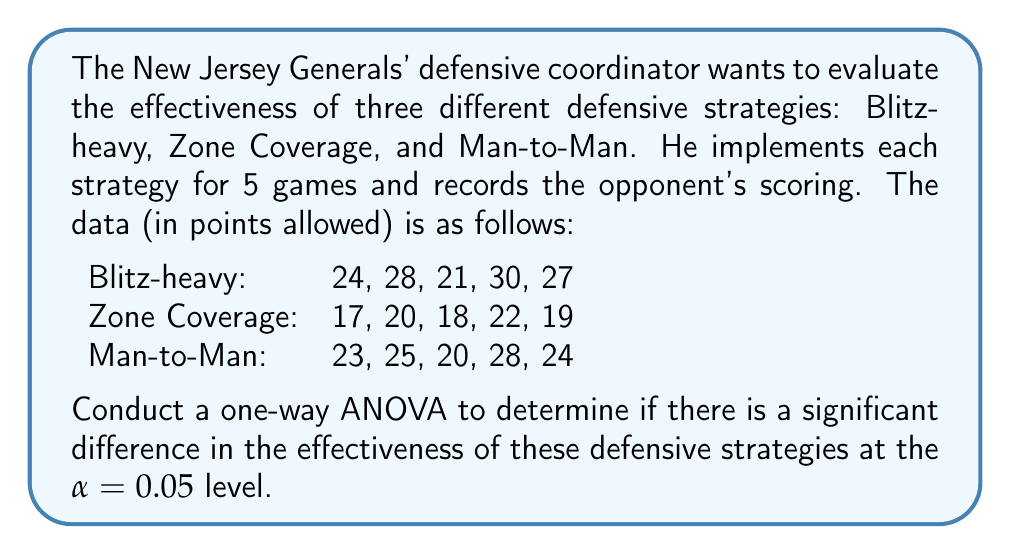Can you answer this question? To conduct a one-way ANOVA, we'll follow these steps:

1. Calculate the sum of squares between groups (SSB), within groups (SSW), and total (SST).
2. Calculate the degrees of freedom for between groups (dfB), within groups (dfW), and total (dfT).
3. Calculate the mean square between groups (MSB) and within groups (MSW).
4. Calculate the F-statistic.
5. Compare the F-statistic to the critical F-value.

Step 1: Calculate sums of squares

First, we need to calculate the grand mean:
$\bar{X} = \frac{24+28+21+30+27+17+20+18+22+19+23+25+20+28+24}{15} = 23.07$

Now, we can calculate SSB, SSW, and SST:

SSB = $5[(26-23.07)^2 + (19.2-23.07)^2 + (24-23.07)^2] = 147.25$

SSW = $(24-26)^2 + (28-26)^2 + (21-26)^2 + (30-26)^2 + (27-26)^2 + 
       (17-19.2)^2 + (20-19.2)^2 + (18-19.2)^2 + (22-19.2)^2 + (19-19.2)^2 +
       (23-24)^2 + (25-24)^2 + (20-24)^2 + (28-24)^2 + (24-24)^2 = 166.8$

SST = SSB + SSW = 147.25 + 166.8 = 314.05

Step 2: Calculate degrees of freedom

dfB = 3 - 1 = 2
dfW = 15 - 3 = 12
dfT = 15 - 1 = 14

Step 3: Calculate mean squares

MSB = SSB / dfB = 147.25 / 2 = 73.625
MSW = SSW / dfW = 166.8 / 12 = 13.9

Step 4: Calculate F-statistic

$F = \frac{MSB}{MSW} = \frac{73.625}{13.9} = 5.30$

Step 5: Compare F-statistic to critical F-value

The critical F-value for $\alpha = 0.05$, dfB = 2, and dfW = 12 is approximately 3.89.

Since our calculated F-statistic (5.30) is greater than the critical F-value (3.89), we reject the null hypothesis.
Answer: The one-way ANOVA results show a significant difference in the effectiveness of the three defensive strategies (F(2,12) = 5.30, p < 0.05). Therefore, we conclude that at least one of the defensive strategies has a significantly different effect on the opponent's scoring compared to the others. 